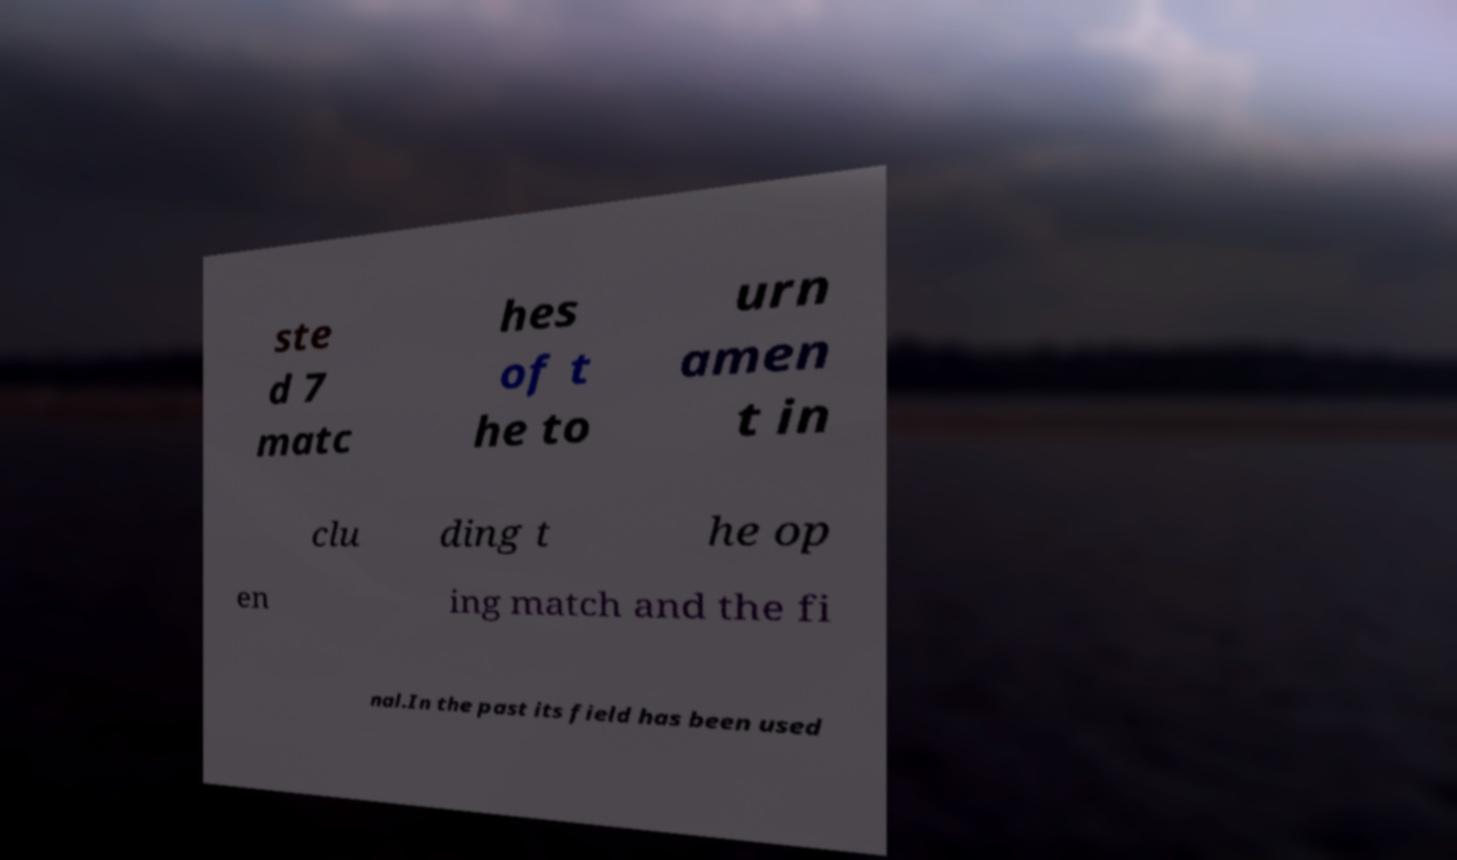I need the written content from this picture converted into text. Can you do that? ste d 7 matc hes of t he to urn amen t in clu ding t he op en ing match and the fi nal.In the past its field has been used 